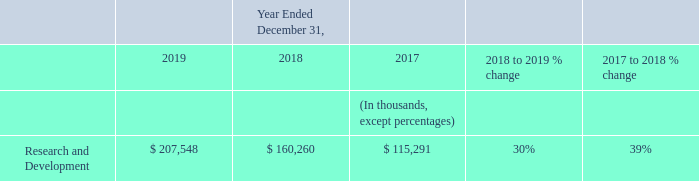Operating Expenses
Research and Development Expenses
Research and development expenses increased $47 million, or 30%, in 2019 compared to 2018. The overall increase was primarily due to increased employee compensation-related costs of $34 million, driven by headcount growth, and increased allocated shared costs of $8 million.
Research and development expenses increased $45 million, or 39%, in 2018 compared to 2017. The overall increase was primarily due to increased employee compensation-related costs of $36 million, driven by headcount growth, and increased allocated shared costs of $6 million.
How much was the increase in Research and Development expenses from 2018 to 2019? $47 million. What are the primary components in the increase of Research and Development from 2017 to 2018?  The overall increase was primarily due to increased employee compensation-related costs of $36 million, driven by headcount growth, and increased allocated shared costs of $6 million. What is the difference in the increase between Research and Development expenses from 2018 to 2019 and 2017 to 2018?
Answer scale should be: million. $47 million - $45 million 
Answer: 2. What is the driver for an increase in employee compensation-related costs in 2019? Driven by headcount growth. What is the percentage increase in Research and Development expense from 2017 to 2019?
Answer scale should be: percent. ((207,548 - 115,291)/115,291) 
Answer: 80.02. What is the total increase in allocated shared costs from 2017 to 2019?
Answer scale should be: million. 6 + 8 
Answer: 14. 